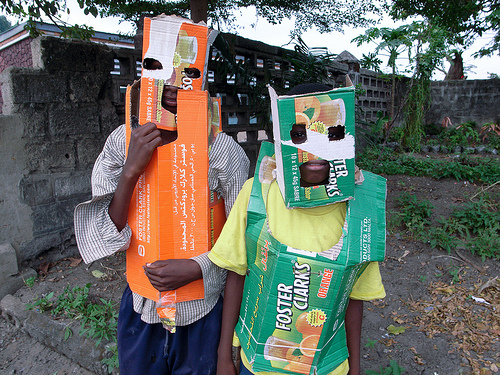<image>
Is the child on the box? No. The child is not positioned on the box. They may be near each other, but the child is not supported by or resting on top of the box. 